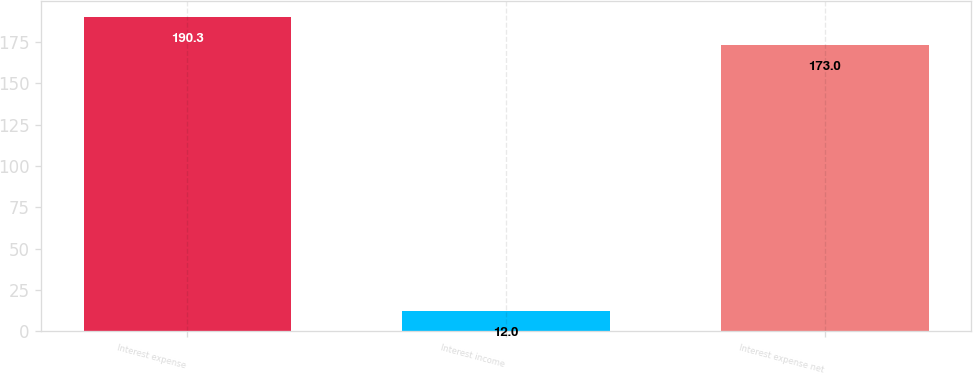<chart> <loc_0><loc_0><loc_500><loc_500><bar_chart><fcel>Interest expense<fcel>Interest income<fcel>Interest expense net<nl><fcel>190.3<fcel>12<fcel>173<nl></chart> 